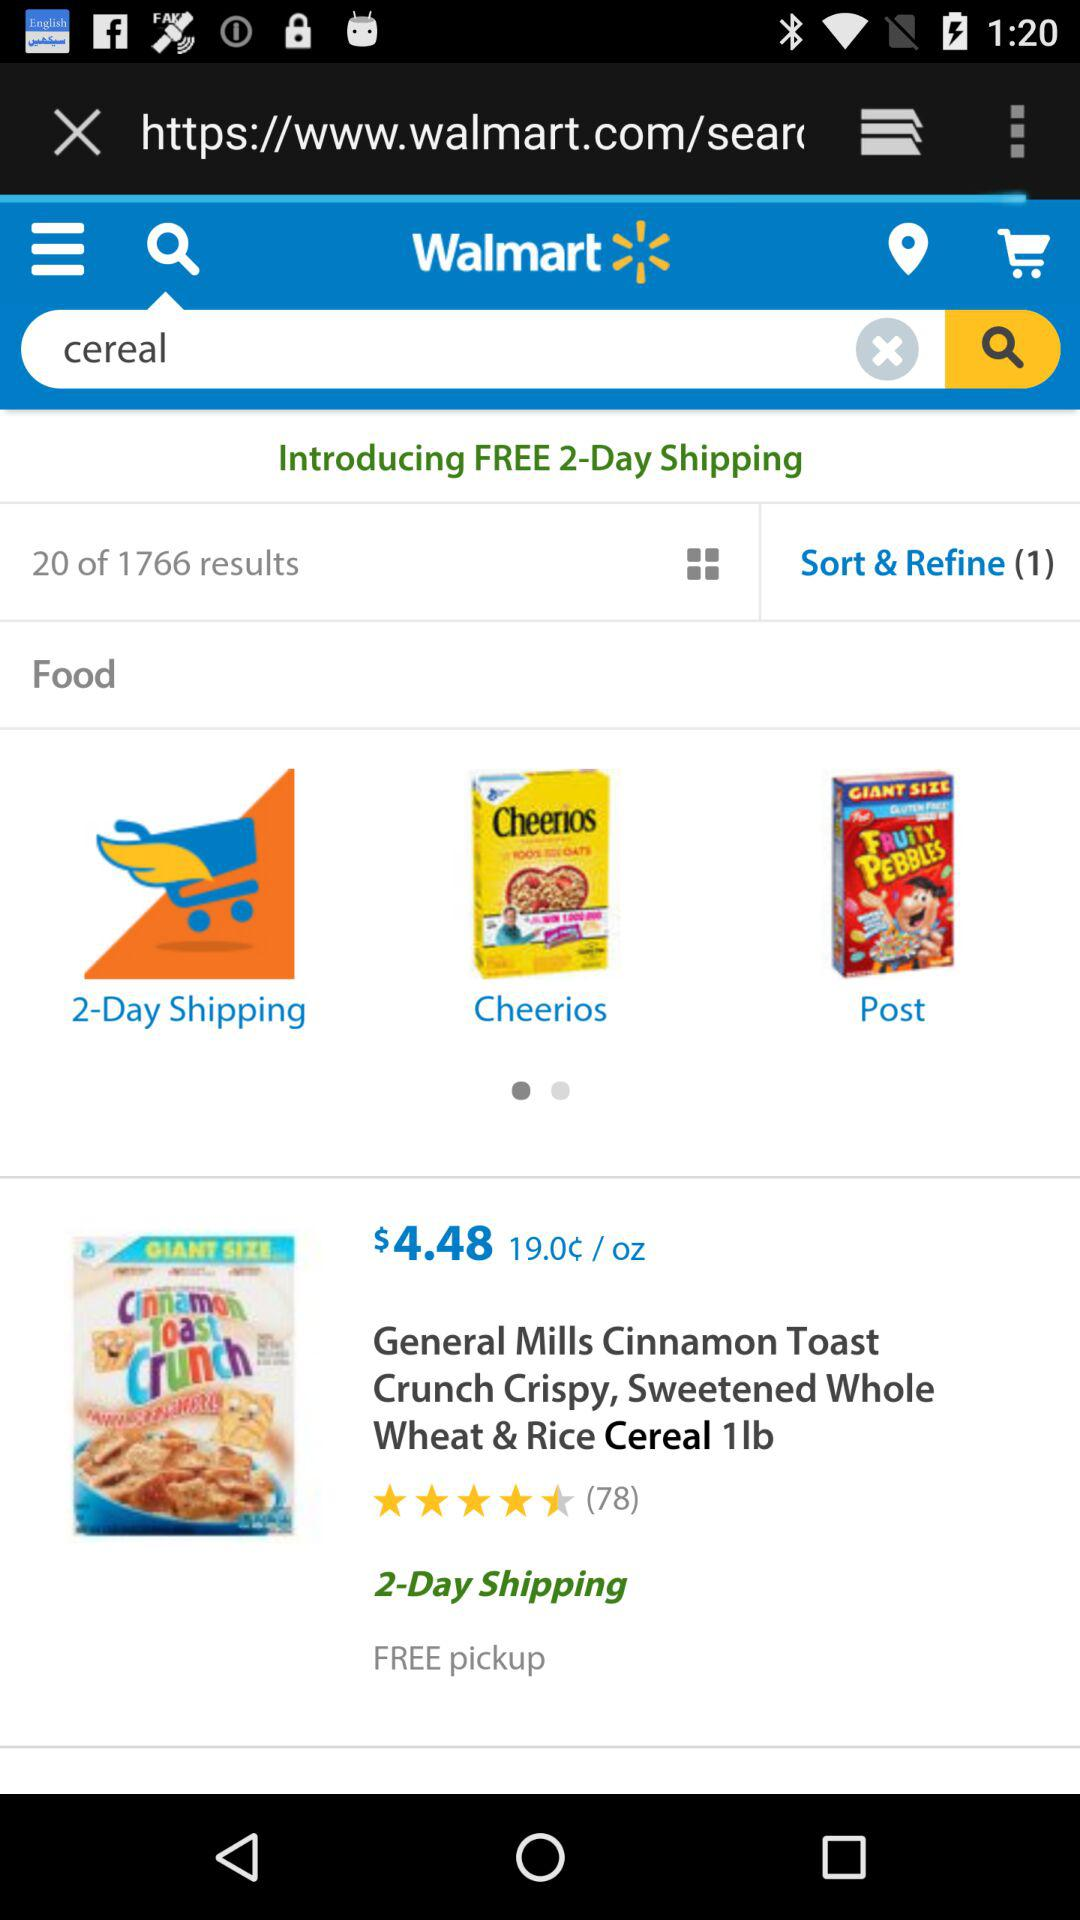What's the total number of results? The total number of results is 1766. 